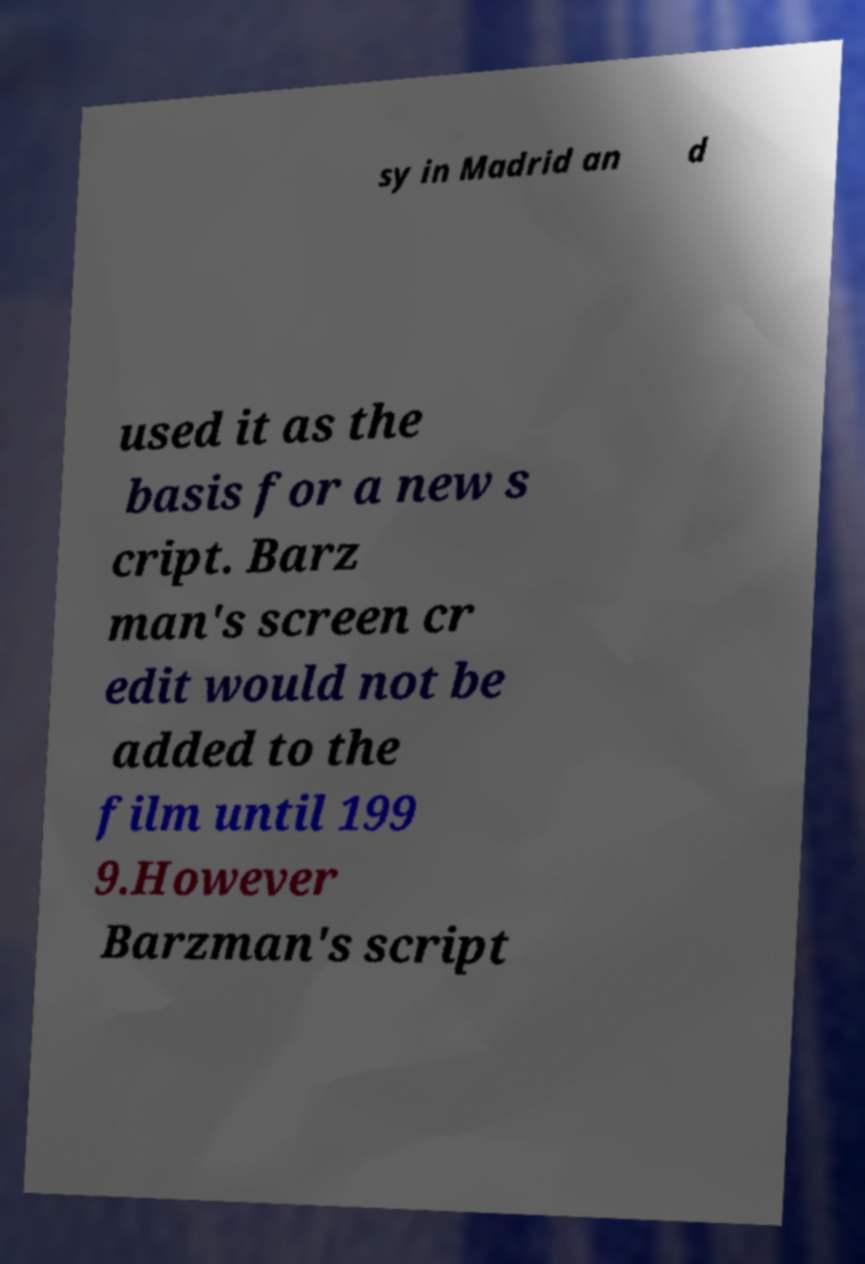I need the written content from this picture converted into text. Can you do that? sy in Madrid an d used it as the basis for a new s cript. Barz man's screen cr edit would not be added to the film until 199 9.However Barzman's script 